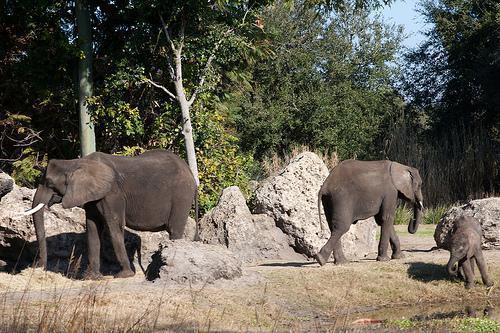How many elephants are pictured here?
Give a very brief answer. 3. How many baby elephants are pictured?
Give a very brief answer. 1. 